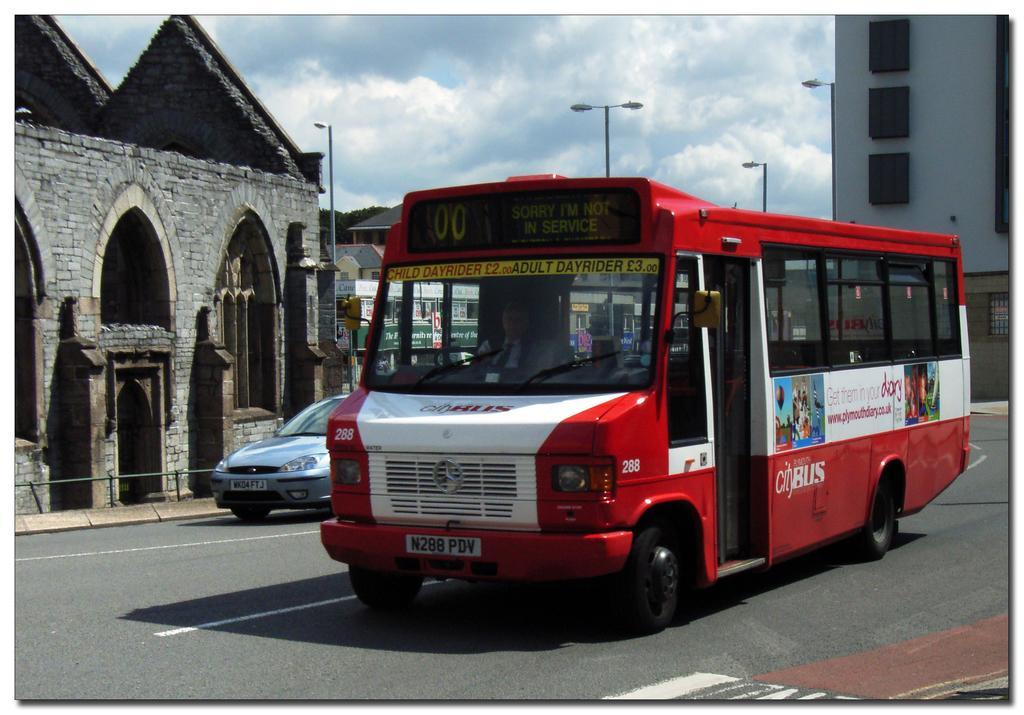Could you give a brief overview of what you see in this image? In the center of the image we can see the vehicles on the road. On the left side of the image we can see building and a street light. In the right side we can see an building and a light pole. In the background there are sky and clouds. 